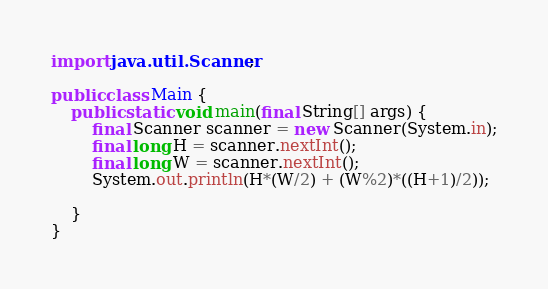Convert code to text. <code><loc_0><loc_0><loc_500><loc_500><_Java_>import java.util.Scanner;
 
public class Main {
    public static void main(final String[] args) {
        final Scanner scanner = new Scanner(System.in);
        final long H = scanner.nextInt();
        final long W = scanner.nextInt();
        System.out.println(H*(W/2) + (W%2)*((H+1)/2));

    }
}</code> 